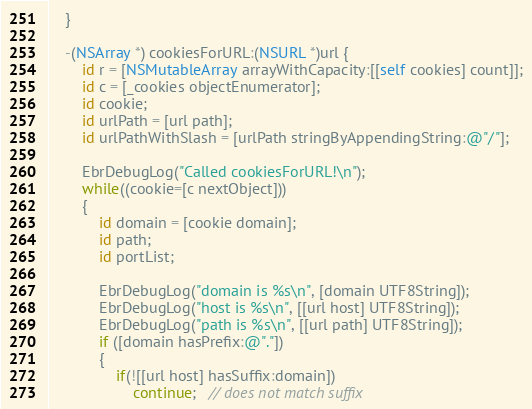Convert code to text. <code><loc_0><loc_0><loc_500><loc_500><_ObjectiveC_>    }

    -(NSArray *) cookiesForURL:(NSURL *)url {
        id r = [NSMutableArray arrayWithCapacity:[[self cookies] count]];
        id c = [_cookies objectEnumerator];
        id cookie;
        id urlPath = [url path];
        id urlPathWithSlash = [urlPath stringByAppendingString:@"/"];

        EbrDebugLog("Called cookiesForURL!\n");
        while((cookie=[c nextObject]))
        {
            id domain = [cookie domain];
            id path;
            id portList;

            EbrDebugLog("domain is %s\n", [domain UTF8String]);
            EbrDebugLog("host is %s\n", [[url host] UTF8String]);
            EbrDebugLog("path is %s\n", [[url path] UTF8String]);
            if ([domain hasPrefix:@"."])
            {
                if(![[url host] hasSuffix:domain])
                    continue;   // does not match suffix</code> 